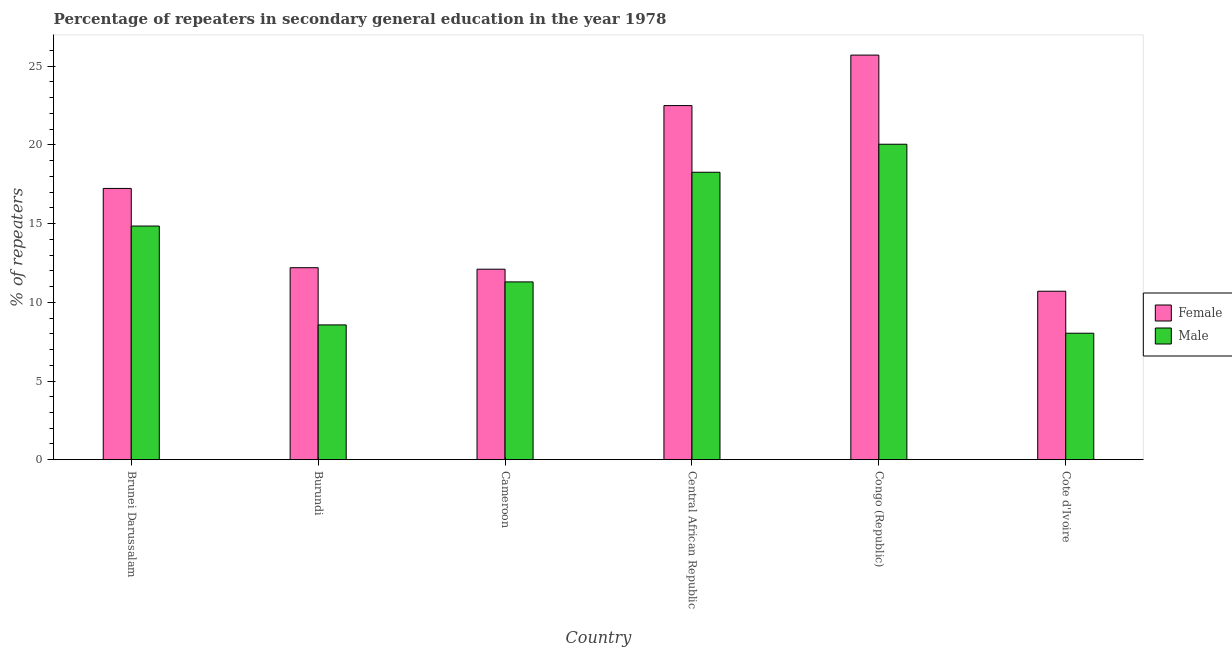How many groups of bars are there?
Provide a succinct answer. 6. Are the number of bars per tick equal to the number of legend labels?
Offer a terse response. Yes. How many bars are there on the 5th tick from the left?
Ensure brevity in your answer.  2. How many bars are there on the 5th tick from the right?
Ensure brevity in your answer.  2. What is the label of the 3rd group of bars from the left?
Provide a short and direct response. Cameroon. In how many cases, is the number of bars for a given country not equal to the number of legend labels?
Give a very brief answer. 0. What is the percentage of male repeaters in Brunei Darussalam?
Provide a succinct answer. 14.85. Across all countries, what is the maximum percentage of female repeaters?
Offer a very short reply. 25.71. Across all countries, what is the minimum percentage of female repeaters?
Your response must be concise. 10.7. In which country was the percentage of male repeaters maximum?
Your answer should be compact. Congo (Republic). In which country was the percentage of male repeaters minimum?
Your answer should be very brief. Cote d'Ivoire. What is the total percentage of male repeaters in the graph?
Your response must be concise. 81.05. What is the difference between the percentage of male repeaters in Burundi and that in Central African Republic?
Give a very brief answer. -9.7. What is the difference between the percentage of male repeaters in Brunei Darussalam and the percentage of female repeaters in Burundi?
Keep it short and to the point. 2.65. What is the average percentage of male repeaters per country?
Provide a succinct answer. 13.51. What is the difference between the percentage of female repeaters and percentage of male repeaters in Cote d'Ivoire?
Provide a short and direct response. 2.67. What is the ratio of the percentage of male repeaters in Cameroon to that in Central African Republic?
Give a very brief answer. 0.62. What is the difference between the highest and the second highest percentage of female repeaters?
Provide a succinct answer. 3.21. What is the difference between the highest and the lowest percentage of female repeaters?
Your answer should be compact. 15. In how many countries, is the percentage of female repeaters greater than the average percentage of female repeaters taken over all countries?
Offer a terse response. 3. What does the 2nd bar from the right in Burundi represents?
Provide a succinct answer. Female. How many countries are there in the graph?
Provide a succinct answer. 6. Does the graph contain grids?
Give a very brief answer. No. Where does the legend appear in the graph?
Make the answer very short. Center right. What is the title of the graph?
Give a very brief answer. Percentage of repeaters in secondary general education in the year 1978. Does "Tetanus" appear as one of the legend labels in the graph?
Keep it short and to the point. No. What is the label or title of the X-axis?
Ensure brevity in your answer.  Country. What is the label or title of the Y-axis?
Your response must be concise. % of repeaters. What is the % of repeaters in Female in Brunei Darussalam?
Ensure brevity in your answer.  17.24. What is the % of repeaters in Male in Brunei Darussalam?
Your answer should be very brief. 14.85. What is the % of repeaters of Female in Burundi?
Offer a very short reply. 12.2. What is the % of repeaters of Male in Burundi?
Offer a very short reply. 8.56. What is the % of repeaters in Female in Cameroon?
Your answer should be very brief. 12.1. What is the % of repeaters in Male in Cameroon?
Offer a very short reply. 11.3. What is the % of repeaters of Female in Central African Republic?
Keep it short and to the point. 22.5. What is the % of repeaters of Male in Central African Republic?
Give a very brief answer. 18.26. What is the % of repeaters of Female in Congo (Republic)?
Your response must be concise. 25.71. What is the % of repeaters in Male in Congo (Republic)?
Make the answer very short. 20.04. What is the % of repeaters of Female in Cote d'Ivoire?
Make the answer very short. 10.7. What is the % of repeaters in Male in Cote d'Ivoire?
Offer a terse response. 8.04. Across all countries, what is the maximum % of repeaters in Female?
Offer a terse response. 25.71. Across all countries, what is the maximum % of repeaters of Male?
Make the answer very short. 20.04. Across all countries, what is the minimum % of repeaters in Female?
Keep it short and to the point. 10.7. Across all countries, what is the minimum % of repeaters in Male?
Make the answer very short. 8.04. What is the total % of repeaters of Female in the graph?
Your answer should be compact. 100.45. What is the total % of repeaters in Male in the graph?
Ensure brevity in your answer.  81.05. What is the difference between the % of repeaters in Female in Brunei Darussalam and that in Burundi?
Your answer should be very brief. 5.04. What is the difference between the % of repeaters of Male in Brunei Darussalam and that in Burundi?
Give a very brief answer. 6.28. What is the difference between the % of repeaters in Female in Brunei Darussalam and that in Cameroon?
Make the answer very short. 5.13. What is the difference between the % of repeaters of Male in Brunei Darussalam and that in Cameroon?
Offer a very short reply. 3.55. What is the difference between the % of repeaters of Female in Brunei Darussalam and that in Central African Republic?
Keep it short and to the point. -5.26. What is the difference between the % of repeaters in Male in Brunei Darussalam and that in Central African Republic?
Make the answer very short. -3.42. What is the difference between the % of repeaters of Female in Brunei Darussalam and that in Congo (Republic)?
Keep it short and to the point. -8.47. What is the difference between the % of repeaters of Male in Brunei Darussalam and that in Congo (Republic)?
Provide a short and direct response. -5.2. What is the difference between the % of repeaters of Female in Brunei Darussalam and that in Cote d'Ivoire?
Your response must be concise. 6.53. What is the difference between the % of repeaters in Male in Brunei Darussalam and that in Cote d'Ivoire?
Offer a terse response. 6.81. What is the difference between the % of repeaters in Female in Burundi and that in Cameroon?
Provide a short and direct response. 0.09. What is the difference between the % of repeaters in Male in Burundi and that in Cameroon?
Your answer should be very brief. -2.73. What is the difference between the % of repeaters in Female in Burundi and that in Central African Republic?
Your answer should be compact. -10.3. What is the difference between the % of repeaters of Male in Burundi and that in Central African Republic?
Your response must be concise. -9.7. What is the difference between the % of repeaters of Female in Burundi and that in Congo (Republic)?
Ensure brevity in your answer.  -13.51. What is the difference between the % of repeaters in Male in Burundi and that in Congo (Republic)?
Offer a very short reply. -11.48. What is the difference between the % of repeaters in Female in Burundi and that in Cote d'Ivoire?
Offer a terse response. 1.49. What is the difference between the % of repeaters of Male in Burundi and that in Cote d'Ivoire?
Provide a succinct answer. 0.53. What is the difference between the % of repeaters in Female in Cameroon and that in Central African Republic?
Provide a short and direct response. -10.4. What is the difference between the % of repeaters in Male in Cameroon and that in Central African Republic?
Keep it short and to the point. -6.97. What is the difference between the % of repeaters of Female in Cameroon and that in Congo (Republic)?
Offer a very short reply. -13.6. What is the difference between the % of repeaters in Male in Cameroon and that in Congo (Republic)?
Your answer should be very brief. -8.75. What is the difference between the % of repeaters in Female in Cameroon and that in Cote d'Ivoire?
Your response must be concise. 1.4. What is the difference between the % of repeaters in Male in Cameroon and that in Cote d'Ivoire?
Offer a very short reply. 3.26. What is the difference between the % of repeaters of Female in Central African Republic and that in Congo (Republic)?
Your answer should be very brief. -3.21. What is the difference between the % of repeaters in Male in Central African Republic and that in Congo (Republic)?
Keep it short and to the point. -1.78. What is the difference between the % of repeaters in Female in Central African Republic and that in Cote d'Ivoire?
Make the answer very short. 11.79. What is the difference between the % of repeaters of Male in Central African Republic and that in Cote d'Ivoire?
Keep it short and to the point. 10.23. What is the difference between the % of repeaters in Female in Congo (Republic) and that in Cote d'Ivoire?
Keep it short and to the point. 15. What is the difference between the % of repeaters of Male in Congo (Republic) and that in Cote d'Ivoire?
Your response must be concise. 12.01. What is the difference between the % of repeaters in Female in Brunei Darussalam and the % of repeaters in Male in Burundi?
Provide a succinct answer. 8.67. What is the difference between the % of repeaters in Female in Brunei Darussalam and the % of repeaters in Male in Cameroon?
Provide a short and direct response. 5.94. What is the difference between the % of repeaters in Female in Brunei Darussalam and the % of repeaters in Male in Central African Republic?
Make the answer very short. -1.03. What is the difference between the % of repeaters of Female in Brunei Darussalam and the % of repeaters of Male in Congo (Republic)?
Ensure brevity in your answer.  -2.81. What is the difference between the % of repeaters in Female in Brunei Darussalam and the % of repeaters in Male in Cote d'Ivoire?
Provide a succinct answer. 9.2. What is the difference between the % of repeaters in Female in Burundi and the % of repeaters in Male in Cameroon?
Provide a short and direct response. 0.9. What is the difference between the % of repeaters of Female in Burundi and the % of repeaters of Male in Central African Republic?
Your response must be concise. -6.06. What is the difference between the % of repeaters of Female in Burundi and the % of repeaters of Male in Congo (Republic)?
Give a very brief answer. -7.84. What is the difference between the % of repeaters in Female in Burundi and the % of repeaters in Male in Cote d'Ivoire?
Provide a succinct answer. 4.16. What is the difference between the % of repeaters in Female in Cameroon and the % of repeaters in Male in Central African Republic?
Keep it short and to the point. -6.16. What is the difference between the % of repeaters in Female in Cameroon and the % of repeaters in Male in Congo (Republic)?
Provide a short and direct response. -7.94. What is the difference between the % of repeaters in Female in Cameroon and the % of repeaters in Male in Cote d'Ivoire?
Keep it short and to the point. 4.07. What is the difference between the % of repeaters in Female in Central African Republic and the % of repeaters in Male in Congo (Republic)?
Your response must be concise. 2.46. What is the difference between the % of repeaters in Female in Central African Republic and the % of repeaters in Male in Cote d'Ivoire?
Give a very brief answer. 14.46. What is the difference between the % of repeaters of Female in Congo (Republic) and the % of repeaters of Male in Cote d'Ivoire?
Your answer should be compact. 17.67. What is the average % of repeaters in Female per country?
Offer a terse response. 16.74. What is the average % of repeaters of Male per country?
Give a very brief answer. 13.51. What is the difference between the % of repeaters of Female and % of repeaters of Male in Brunei Darussalam?
Your answer should be very brief. 2.39. What is the difference between the % of repeaters in Female and % of repeaters in Male in Burundi?
Ensure brevity in your answer.  3.64. What is the difference between the % of repeaters in Female and % of repeaters in Male in Cameroon?
Your response must be concise. 0.81. What is the difference between the % of repeaters in Female and % of repeaters in Male in Central African Republic?
Make the answer very short. 4.24. What is the difference between the % of repeaters of Female and % of repeaters of Male in Congo (Republic)?
Make the answer very short. 5.66. What is the difference between the % of repeaters in Female and % of repeaters in Male in Cote d'Ivoire?
Make the answer very short. 2.67. What is the ratio of the % of repeaters of Female in Brunei Darussalam to that in Burundi?
Offer a terse response. 1.41. What is the ratio of the % of repeaters in Male in Brunei Darussalam to that in Burundi?
Offer a terse response. 1.73. What is the ratio of the % of repeaters in Female in Brunei Darussalam to that in Cameroon?
Your answer should be very brief. 1.42. What is the ratio of the % of repeaters of Male in Brunei Darussalam to that in Cameroon?
Offer a very short reply. 1.31. What is the ratio of the % of repeaters in Female in Brunei Darussalam to that in Central African Republic?
Make the answer very short. 0.77. What is the ratio of the % of repeaters of Male in Brunei Darussalam to that in Central African Republic?
Give a very brief answer. 0.81. What is the ratio of the % of repeaters in Female in Brunei Darussalam to that in Congo (Republic)?
Your answer should be very brief. 0.67. What is the ratio of the % of repeaters in Male in Brunei Darussalam to that in Congo (Republic)?
Offer a very short reply. 0.74. What is the ratio of the % of repeaters of Female in Brunei Darussalam to that in Cote d'Ivoire?
Make the answer very short. 1.61. What is the ratio of the % of repeaters of Male in Brunei Darussalam to that in Cote d'Ivoire?
Your response must be concise. 1.85. What is the ratio of the % of repeaters in Female in Burundi to that in Cameroon?
Give a very brief answer. 1.01. What is the ratio of the % of repeaters in Male in Burundi to that in Cameroon?
Provide a short and direct response. 0.76. What is the ratio of the % of repeaters in Female in Burundi to that in Central African Republic?
Provide a short and direct response. 0.54. What is the ratio of the % of repeaters of Male in Burundi to that in Central African Republic?
Provide a short and direct response. 0.47. What is the ratio of the % of repeaters of Female in Burundi to that in Congo (Republic)?
Keep it short and to the point. 0.47. What is the ratio of the % of repeaters of Male in Burundi to that in Congo (Republic)?
Ensure brevity in your answer.  0.43. What is the ratio of the % of repeaters of Female in Burundi to that in Cote d'Ivoire?
Provide a succinct answer. 1.14. What is the ratio of the % of repeaters of Male in Burundi to that in Cote d'Ivoire?
Offer a very short reply. 1.07. What is the ratio of the % of repeaters in Female in Cameroon to that in Central African Republic?
Give a very brief answer. 0.54. What is the ratio of the % of repeaters of Male in Cameroon to that in Central African Republic?
Provide a succinct answer. 0.62. What is the ratio of the % of repeaters in Female in Cameroon to that in Congo (Republic)?
Keep it short and to the point. 0.47. What is the ratio of the % of repeaters in Male in Cameroon to that in Congo (Republic)?
Provide a short and direct response. 0.56. What is the ratio of the % of repeaters in Female in Cameroon to that in Cote d'Ivoire?
Offer a very short reply. 1.13. What is the ratio of the % of repeaters in Male in Cameroon to that in Cote d'Ivoire?
Offer a terse response. 1.41. What is the ratio of the % of repeaters of Female in Central African Republic to that in Congo (Republic)?
Keep it short and to the point. 0.88. What is the ratio of the % of repeaters in Male in Central African Republic to that in Congo (Republic)?
Keep it short and to the point. 0.91. What is the ratio of the % of repeaters in Female in Central African Republic to that in Cote d'Ivoire?
Keep it short and to the point. 2.1. What is the ratio of the % of repeaters in Male in Central African Republic to that in Cote d'Ivoire?
Your answer should be compact. 2.27. What is the ratio of the % of repeaters of Female in Congo (Republic) to that in Cote d'Ivoire?
Offer a very short reply. 2.4. What is the ratio of the % of repeaters in Male in Congo (Republic) to that in Cote d'Ivoire?
Give a very brief answer. 2.49. What is the difference between the highest and the second highest % of repeaters of Female?
Provide a short and direct response. 3.21. What is the difference between the highest and the second highest % of repeaters in Male?
Offer a terse response. 1.78. What is the difference between the highest and the lowest % of repeaters of Female?
Your answer should be compact. 15. What is the difference between the highest and the lowest % of repeaters of Male?
Your answer should be compact. 12.01. 